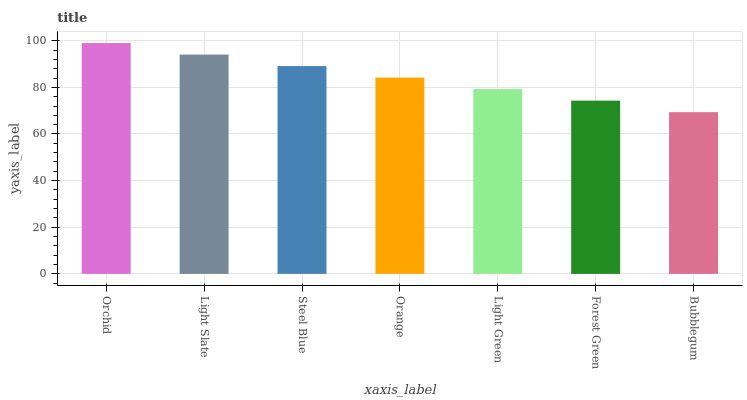Is Bubblegum the minimum?
Answer yes or no. Yes. Is Orchid the maximum?
Answer yes or no. Yes. Is Light Slate the minimum?
Answer yes or no. No. Is Light Slate the maximum?
Answer yes or no. No. Is Orchid greater than Light Slate?
Answer yes or no. Yes. Is Light Slate less than Orchid?
Answer yes or no. Yes. Is Light Slate greater than Orchid?
Answer yes or no. No. Is Orchid less than Light Slate?
Answer yes or no. No. Is Orange the high median?
Answer yes or no. Yes. Is Orange the low median?
Answer yes or no. Yes. Is Light Slate the high median?
Answer yes or no. No. Is Orchid the low median?
Answer yes or no. No. 